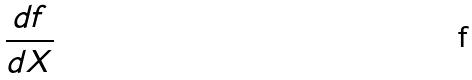<formula> <loc_0><loc_0><loc_500><loc_500>\frac { d f } { d X }</formula> 